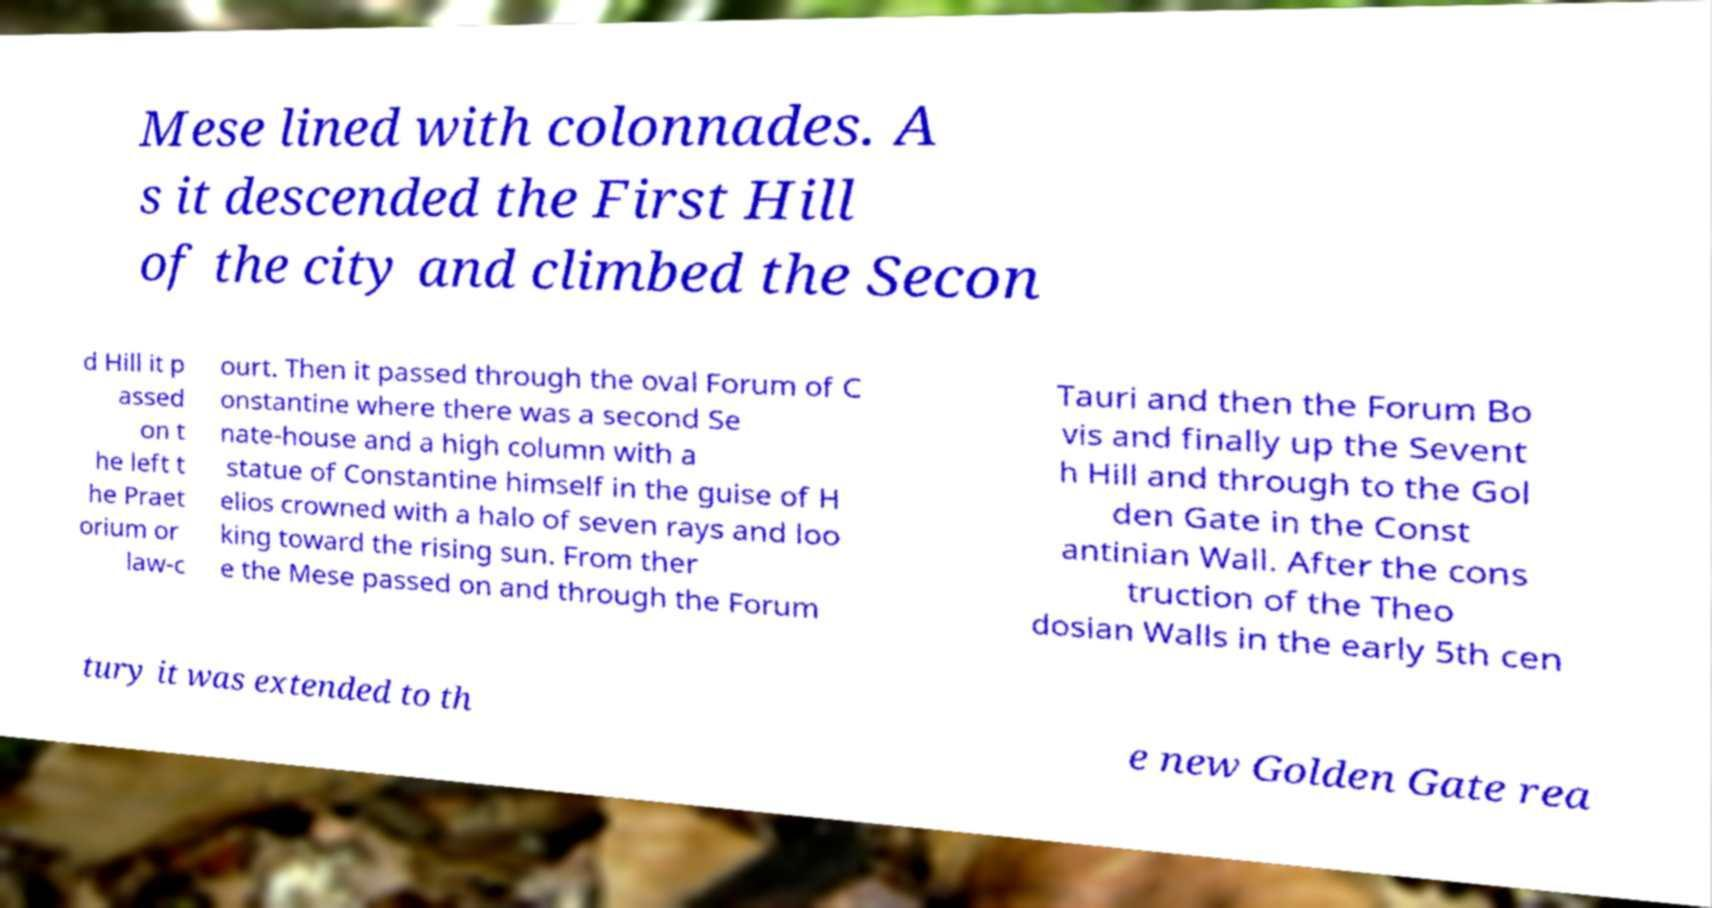There's text embedded in this image that I need extracted. Can you transcribe it verbatim? Mese lined with colonnades. A s it descended the First Hill of the city and climbed the Secon d Hill it p assed on t he left t he Praet orium or law-c ourt. Then it passed through the oval Forum of C onstantine where there was a second Se nate-house and a high column with a statue of Constantine himself in the guise of H elios crowned with a halo of seven rays and loo king toward the rising sun. From ther e the Mese passed on and through the Forum Tauri and then the Forum Bo vis and finally up the Sevent h Hill and through to the Gol den Gate in the Const antinian Wall. After the cons truction of the Theo dosian Walls in the early 5th cen tury it was extended to th e new Golden Gate rea 